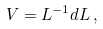Convert formula to latex. <formula><loc_0><loc_0><loc_500><loc_500>V = L ^ { - 1 } d L \, ,</formula> 